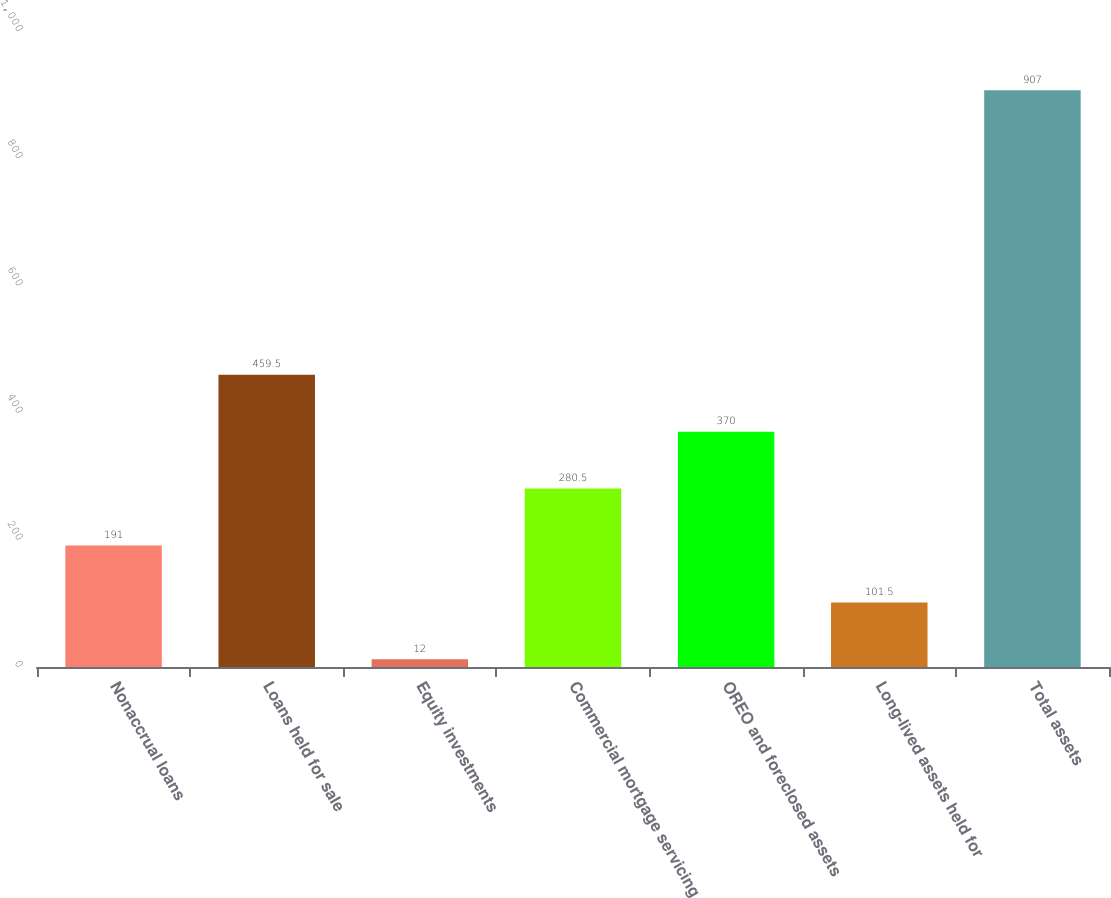<chart> <loc_0><loc_0><loc_500><loc_500><bar_chart><fcel>Nonaccrual loans<fcel>Loans held for sale<fcel>Equity investments<fcel>Commercial mortgage servicing<fcel>OREO and foreclosed assets<fcel>Long-lived assets held for<fcel>Total assets<nl><fcel>191<fcel>459.5<fcel>12<fcel>280.5<fcel>370<fcel>101.5<fcel>907<nl></chart> 